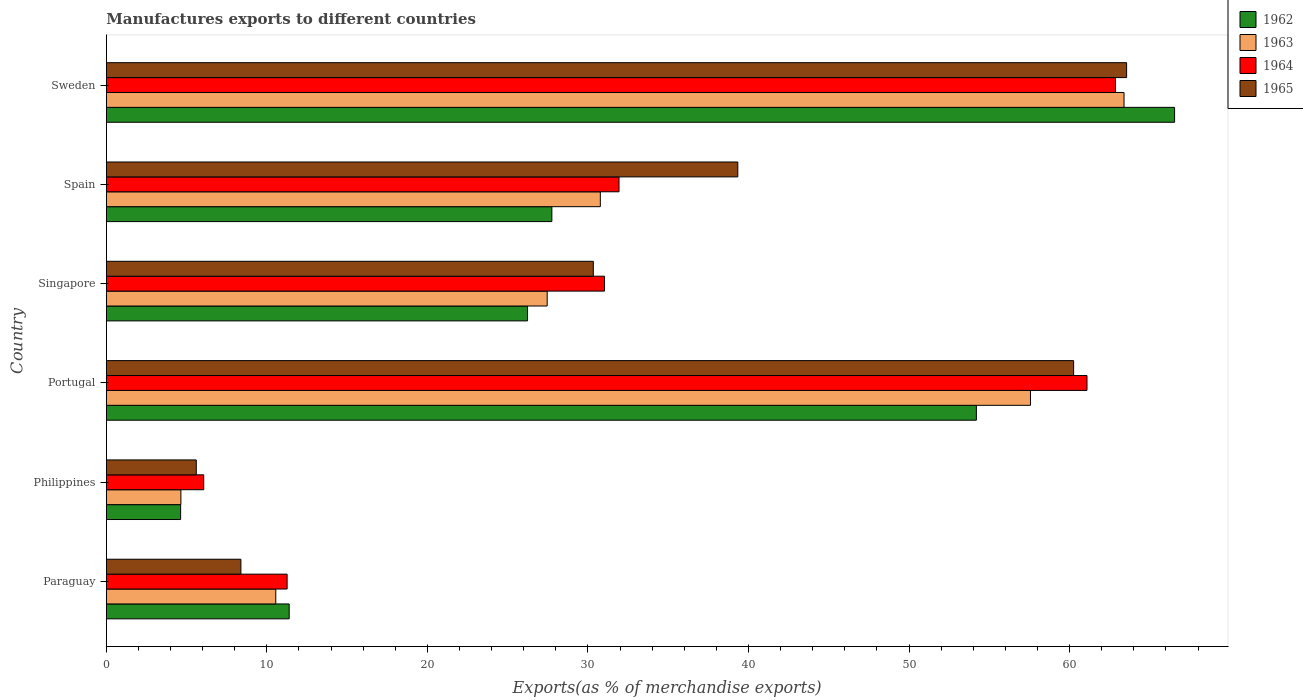Are the number of bars per tick equal to the number of legend labels?
Offer a terse response. Yes. In how many cases, is the number of bars for a given country not equal to the number of legend labels?
Offer a terse response. 0. What is the percentage of exports to different countries in 1965 in Sweden?
Ensure brevity in your answer.  63.55. Across all countries, what is the maximum percentage of exports to different countries in 1964?
Keep it short and to the point. 62.86. Across all countries, what is the minimum percentage of exports to different countries in 1962?
Offer a very short reply. 4.63. In which country was the percentage of exports to different countries in 1965 maximum?
Your answer should be very brief. Sweden. What is the total percentage of exports to different countries in 1965 in the graph?
Give a very brief answer. 207.45. What is the difference between the percentage of exports to different countries in 1964 in Portugal and that in Sweden?
Make the answer very short. -1.77. What is the difference between the percentage of exports to different countries in 1962 in Sweden and the percentage of exports to different countries in 1964 in Philippines?
Ensure brevity in your answer.  60.47. What is the average percentage of exports to different countries in 1964 per country?
Give a very brief answer. 34.04. What is the difference between the percentage of exports to different countries in 1962 and percentage of exports to different countries in 1963 in Paraguay?
Give a very brief answer. 0.83. In how many countries, is the percentage of exports to different countries in 1963 greater than 22 %?
Provide a succinct answer. 4. What is the ratio of the percentage of exports to different countries in 1964 in Portugal to that in Singapore?
Your answer should be compact. 1.97. Is the difference between the percentage of exports to different countries in 1962 in Paraguay and Portugal greater than the difference between the percentage of exports to different countries in 1963 in Paraguay and Portugal?
Your response must be concise. Yes. What is the difference between the highest and the second highest percentage of exports to different countries in 1962?
Your answer should be compact. 12.35. What is the difference between the highest and the lowest percentage of exports to different countries in 1965?
Provide a succinct answer. 57.95. In how many countries, is the percentage of exports to different countries in 1965 greater than the average percentage of exports to different countries in 1965 taken over all countries?
Provide a succinct answer. 3. What does the 1st bar from the top in Singapore represents?
Offer a terse response. 1965. What does the 4th bar from the bottom in Philippines represents?
Make the answer very short. 1965. Is it the case that in every country, the sum of the percentage of exports to different countries in 1964 and percentage of exports to different countries in 1965 is greater than the percentage of exports to different countries in 1963?
Provide a succinct answer. Yes. Are all the bars in the graph horizontal?
Provide a succinct answer. Yes. Does the graph contain grids?
Provide a succinct answer. No. How many legend labels are there?
Your response must be concise. 4. How are the legend labels stacked?
Make the answer very short. Vertical. What is the title of the graph?
Your answer should be very brief. Manufactures exports to different countries. Does "1995" appear as one of the legend labels in the graph?
Give a very brief answer. No. What is the label or title of the X-axis?
Your response must be concise. Exports(as % of merchandise exports). What is the Exports(as % of merchandise exports) of 1962 in Paraguay?
Your answer should be compact. 11.39. What is the Exports(as % of merchandise exports) in 1963 in Paraguay?
Provide a short and direct response. 10.55. What is the Exports(as % of merchandise exports) in 1964 in Paraguay?
Give a very brief answer. 11.26. What is the Exports(as % of merchandise exports) of 1965 in Paraguay?
Make the answer very short. 8.38. What is the Exports(as % of merchandise exports) of 1962 in Philippines?
Provide a succinct answer. 4.63. What is the Exports(as % of merchandise exports) of 1963 in Philippines?
Provide a short and direct response. 4.64. What is the Exports(as % of merchandise exports) in 1964 in Philippines?
Your answer should be very brief. 6.07. What is the Exports(as % of merchandise exports) of 1965 in Philippines?
Keep it short and to the point. 5.6. What is the Exports(as % of merchandise exports) in 1962 in Portugal?
Ensure brevity in your answer.  54.19. What is the Exports(as % of merchandise exports) in 1963 in Portugal?
Provide a short and direct response. 57.56. What is the Exports(as % of merchandise exports) of 1964 in Portugal?
Provide a succinct answer. 61.08. What is the Exports(as % of merchandise exports) in 1965 in Portugal?
Your response must be concise. 60.25. What is the Exports(as % of merchandise exports) in 1962 in Singapore?
Offer a terse response. 26.24. What is the Exports(as % of merchandise exports) of 1963 in Singapore?
Keep it short and to the point. 27.46. What is the Exports(as % of merchandise exports) of 1964 in Singapore?
Provide a short and direct response. 31.03. What is the Exports(as % of merchandise exports) of 1965 in Singapore?
Your response must be concise. 30.33. What is the Exports(as % of merchandise exports) of 1962 in Spain?
Offer a very short reply. 27.75. What is the Exports(as % of merchandise exports) in 1963 in Spain?
Provide a succinct answer. 30.77. What is the Exports(as % of merchandise exports) of 1964 in Spain?
Your answer should be compact. 31.93. What is the Exports(as % of merchandise exports) in 1965 in Spain?
Keep it short and to the point. 39.33. What is the Exports(as % of merchandise exports) in 1962 in Sweden?
Your answer should be very brief. 66.54. What is the Exports(as % of merchandise exports) of 1963 in Sweden?
Provide a short and direct response. 63.39. What is the Exports(as % of merchandise exports) in 1964 in Sweden?
Provide a short and direct response. 62.86. What is the Exports(as % of merchandise exports) in 1965 in Sweden?
Offer a very short reply. 63.55. Across all countries, what is the maximum Exports(as % of merchandise exports) of 1962?
Offer a very short reply. 66.54. Across all countries, what is the maximum Exports(as % of merchandise exports) of 1963?
Keep it short and to the point. 63.39. Across all countries, what is the maximum Exports(as % of merchandise exports) in 1964?
Provide a short and direct response. 62.86. Across all countries, what is the maximum Exports(as % of merchandise exports) of 1965?
Your answer should be very brief. 63.55. Across all countries, what is the minimum Exports(as % of merchandise exports) in 1962?
Offer a terse response. 4.63. Across all countries, what is the minimum Exports(as % of merchandise exports) in 1963?
Your answer should be compact. 4.64. Across all countries, what is the minimum Exports(as % of merchandise exports) in 1964?
Give a very brief answer. 6.07. Across all countries, what is the minimum Exports(as % of merchandise exports) of 1965?
Make the answer very short. 5.6. What is the total Exports(as % of merchandise exports) in 1962 in the graph?
Offer a terse response. 190.73. What is the total Exports(as % of merchandise exports) of 1963 in the graph?
Your answer should be compact. 194.38. What is the total Exports(as % of merchandise exports) in 1964 in the graph?
Ensure brevity in your answer.  204.23. What is the total Exports(as % of merchandise exports) of 1965 in the graph?
Your answer should be very brief. 207.45. What is the difference between the Exports(as % of merchandise exports) in 1962 in Paraguay and that in Philippines?
Keep it short and to the point. 6.76. What is the difference between the Exports(as % of merchandise exports) in 1963 in Paraguay and that in Philippines?
Keep it short and to the point. 5.91. What is the difference between the Exports(as % of merchandise exports) of 1964 in Paraguay and that in Philippines?
Your response must be concise. 5.19. What is the difference between the Exports(as % of merchandise exports) in 1965 in Paraguay and that in Philippines?
Give a very brief answer. 2.78. What is the difference between the Exports(as % of merchandise exports) of 1962 in Paraguay and that in Portugal?
Your answer should be compact. -42.8. What is the difference between the Exports(as % of merchandise exports) in 1963 in Paraguay and that in Portugal?
Give a very brief answer. -47.01. What is the difference between the Exports(as % of merchandise exports) in 1964 in Paraguay and that in Portugal?
Keep it short and to the point. -49.82. What is the difference between the Exports(as % of merchandise exports) of 1965 in Paraguay and that in Portugal?
Your answer should be very brief. -51.87. What is the difference between the Exports(as % of merchandise exports) in 1962 in Paraguay and that in Singapore?
Offer a terse response. -14.85. What is the difference between the Exports(as % of merchandise exports) of 1963 in Paraguay and that in Singapore?
Offer a terse response. -16.91. What is the difference between the Exports(as % of merchandise exports) of 1964 in Paraguay and that in Singapore?
Provide a succinct answer. -19.77. What is the difference between the Exports(as % of merchandise exports) in 1965 in Paraguay and that in Singapore?
Provide a succinct answer. -21.95. What is the difference between the Exports(as % of merchandise exports) of 1962 in Paraguay and that in Spain?
Ensure brevity in your answer.  -16.36. What is the difference between the Exports(as % of merchandise exports) of 1963 in Paraguay and that in Spain?
Offer a very short reply. -20.22. What is the difference between the Exports(as % of merchandise exports) of 1964 in Paraguay and that in Spain?
Offer a terse response. -20.67. What is the difference between the Exports(as % of merchandise exports) of 1965 in Paraguay and that in Spain?
Your answer should be very brief. -30.95. What is the difference between the Exports(as % of merchandise exports) of 1962 in Paraguay and that in Sweden?
Your answer should be compact. -55.15. What is the difference between the Exports(as % of merchandise exports) in 1963 in Paraguay and that in Sweden?
Ensure brevity in your answer.  -52.83. What is the difference between the Exports(as % of merchandise exports) in 1964 in Paraguay and that in Sweden?
Make the answer very short. -51.6. What is the difference between the Exports(as % of merchandise exports) of 1965 in Paraguay and that in Sweden?
Ensure brevity in your answer.  -55.17. What is the difference between the Exports(as % of merchandise exports) in 1962 in Philippines and that in Portugal?
Offer a terse response. -49.57. What is the difference between the Exports(as % of merchandise exports) in 1963 in Philippines and that in Portugal?
Ensure brevity in your answer.  -52.92. What is the difference between the Exports(as % of merchandise exports) of 1964 in Philippines and that in Portugal?
Your answer should be very brief. -55.02. What is the difference between the Exports(as % of merchandise exports) in 1965 in Philippines and that in Portugal?
Ensure brevity in your answer.  -54.65. What is the difference between the Exports(as % of merchandise exports) in 1962 in Philippines and that in Singapore?
Provide a short and direct response. -21.61. What is the difference between the Exports(as % of merchandise exports) in 1963 in Philippines and that in Singapore?
Your answer should be very brief. -22.82. What is the difference between the Exports(as % of merchandise exports) of 1964 in Philippines and that in Singapore?
Provide a succinct answer. -24.96. What is the difference between the Exports(as % of merchandise exports) in 1965 in Philippines and that in Singapore?
Your response must be concise. -24.73. What is the difference between the Exports(as % of merchandise exports) of 1962 in Philippines and that in Spain?
Offer a very short reply. -23.12. What is the difference between the Exports(as % of merchandise exports) of 1963 in Philippines and that in Spain?
Your response must be concise. -26.13. What is the difference between the Exports(as % of merchandise exports) in 1964 in Philippines and that in Spain?
Provide a short and direct response. -25.87. What is the difference between the Exports(as % of merchandise exports) of 1965 in Philippines and that in Spain?
Provide a short and direct response. -33.73. What is the difference between the Exports(as % of merchandise exports) of 1962 in Philippines and that in Sweden?
Ensure brevity in your answer.  -61.91. What is the difference between the Exports(as % of merchandise exports) in 1963 in Philippines and that in Sweden?
Give a very brief answer. -58.74. What is the difference between the Exports(as % of merchandise exports) in 1964 in Philippines and that in Sweden?
Offer a very short reply. -56.79. What is the difference between the Exports(as % of merchandise exports) of 1965 in Philippines and that in Sweden?
Give a very brief answer. -57.95. What is the difference between the Exports(as % of merchandise exports) of 1962 in Portugal and that in Singapore?
Offer a terse response. 27.96. What is the difference between the Exports(as % of merchandise exports) in 1963 in Portugal and that in Singapore?
Provide a short and direct response. 30.1. What is the difference between the Exports(as % of merchandise exports) of 1964 in Portugal and that in Singapore?
Give a very brief answer. 30.05. What is the difference between the Exports(as % of merchandise exports) in 1965 in Portugal and that in Singapore?
Make the answer very short. 29.92. What is the difference between the Exports(as % of merchandise exports) of 1962 in Portugal and that in Spain?
Keep it short and to the point. 26.44. What is the difference between the Exports(as % of merchandise exports) in 1963 in Portugal and that in Spain?
Offer a terse response. 26.79. What is the difference between the Exports(as % of merchandise exports) of 1964 in Portugal and that in Spain?
Your answer should be compact. 29.15. What is the difference between the Exports(as % of merchandise exports) of 1965 in Portugal and that in Spain?
Ensure brevity in your answer.  20.92. What is the difference between the Exports(as % of merchandise exports) in 1962 in Portugal and that in Sweden?
Your answer should be compact. -12.35. What is the difference between the Exports(as % of merchandise exports) of 1963 in Portugal and that in Sweden?
Your response must be concise. -5.83. What is the difference between the Exports(as % of merchandise exports) in 1964 in Portugal and that in Sweden?
Offer a very short reply. -1.77. What is the difference between the Exports(as % of merchandise exports) of 1965 in Portugal and that in Sweden?
Offer a terse response. -3.3. What is the difference between the Exports(as % of merchandise exports) of 1962 in Singapore and that in Spain?
Ensure brevity in your answer.  -1.51. What is the difference between the Exports(as % of merchandise exports) of 1963 in Singapore and that in Spain?
Provide a succinct answer. -3.31. What is the difference between the Exports(as % of merchandise exports) in 1964 in Singapore and that in Spain?
Your answer should be compact. -0.9. What is the difference between the Exports(as % of merchandise exports) of 1965 in Singapore and that in Spain?
Offer a very short reply. -9. What is the difference between the Exports(as % of merchandise exports) in 1962 in Singapore and that in Sweden?
Offer a very short reply. -40.3. What is the difference between the Exports(as % of merchandise exports) in 1963 in Singapore and that in Sweden?
Make the answer very short. -35.93. What is the difference between the Exports(as % of merchandise exports) of 1964 in Singapore and that in Sweden?
Keep it short and to the point. -31.83. What is the difference between the Exports(as % of merchandise exports) in 1965 in Singapore and that in Sweden?
Make the answer very short. -33.22. What is the difference between the Exports(as % of merchandise exports) in 1962 in Spain and that in Sweden?
Provide a short and direct response. -38.79. What is the difference between the Exports(as % of merchandise exports) of 1963 in Spain and that in Sweden?
Give a very brief answer. -32.62. What is the difference between the Exports(as % of merchandise exports) of 1964 in Spain and that in Sweden?
Make the answer very short. -30.92. What is the difference between the Exports(as % of merchandise exports) of 1965 in Spain and that in Sweden?
Ensure brevity in your answer.  -24.22. What is the difference between the Exports(as % of merchandise exports) in 1962 in Paraguay and the Exports(as % of merchandise exports) in 1963 in Philippines?
Your answer should be very brief. 6.75. What is the difference between the Exports(as % of merchandise exports) of 1962 in Paraguay and the Exports(as % of merchandise exports) of 1964 in Philippines?
Give a very brief answer. 5.32. What is the difference between the Exports(as % of merchandise exports) in 1962 in Paraguay and the Exports(as % of merchandise exports) in 1965 in Philippines?
Provide a short and direct response. 5.79. What is the difference between the Exports(as % of merchandise exports) in 1963 in Paraguay and the Exports(as % of merchandise exports) in 1964 in Philippines?
Your response must be concise. 4.49. What is the difference between the Exports(as % of merchandise exports) in 1963 in Paraguay and the Exports(as % of merchandise exports) in 1965 in Philippines?
Your response must be concise. 4.95. What is the difference between the Exports(as % of merchandise exports) in 1964 in Paraguay and the Exports(as % of merchandise exports) in 1965 in Philippines?
Provide a succinct answer. 5.66. What is the difference between the Exports(as % of merchandise exports) in 1962 in Paraguay and the Exports(as % of merchandise exports) in 1963 in Portugal?
Provide a succinct answer. -46.17. What is the difference between the Exports(as % of merchandise exports) in 1962 in Paraguay and the Exports(as % of merchandise exports) in 1964 in Portugal?
Provide a short and direct response. -49.69. What is the difference between the Exports(as % of merchandise exports) of 1962 in Paraguay and the Exports(as % of merchandise exports) of 1965 in Portugal?
Your answer should be very brief. -48.86. What is the difference between the Exports(as % of merchandise exports) of 1963 in Paraguay and the Exports(as % of merchandise exports) of 1964 in Portugal?
Ensure brevity in your answer.  -50.53. What is the difference between the Exports(as % of merchandise exports) of 1963 in Paraguay and the Exports(as % of merchandise exports) of 1965 in Portugal?
Your answer should be very brief. -49.7. What is the difference between the Exports(as % of merchandise exports) of 1964 in Paraguay and the Exports(as % of merchandise exports) of 1965 in Portugal?
Provide a succinct answer. -48.99. What is the difference between the Exports(as % of merchandise exports) in 1962 in Paraguay and the Exports(as % of merchandise exports) in 1963 in Singapore?
Your answer should be very brief. -16.07. What is the difference between the Exports(as % of merchandise exports) of 1962 in Paraguay and the Exports(as % of merchandise exports) of 1964 in Singapore?
Offer a terse response. -19.64. What is the difference between the Exports(as % of merchandise exports) of 1962 in Paraguay and the Exports(as % of merchandise exports) of 1965 in Singapore?
Provide a succinct answer. -18.94. What is the difference between the Exports(as % of merchandise exports) in 1963 in Paraguay and the Exports(as % of merchandise exports) in 1964 in Singapore?
Your answer should be compact. -20.48. What is the difference between the Exports(as % of merchandise exports) in 1963 in Paraguay and the Exports(as % of merchandise exports) in 1965 in Singapore?
Your answer should be compact. -19.78. What is the difference between the Exports(as % of merchandise exports) of 1964 in Paraguay and the Exports(as % of merchandise exports) of 1965 in Singapore?
Give a very brief answer. -19.07. What is the difference between the Exports(as % of merchandise exports) of 1962 in Paraguay and the Exports(as % of merchandise exports) of 1963 in Spain?
Your answer should be compact. -19.38. What is the difference between the Exports(as % of merchandise exports) in 1962 in Paraguay and the Exports(as % of merchandise exports) in 1964 in Spain?
Make the answer very short. -20.54. What is the difference between the Exports(as % of merchandise exports) of 1962 in Paraguay and the Exports(as % of merchandise exports) of 1965 in Spain?
Make the answer very short. -27.94. What is the difference between the Exports(as % of merchandise exports) of 1963 in Paraguay and the Exports(as % of merchandise exports) of 1964 in Spain?
Ensure brevity in your answer.  -21.38. What is the difference between the Exports(as % of merchandise exports) in 1963 in Paraguay and the Exports(as % of merchandise exports) in 1965 in Spain?
Offer a terse response. -28.78. What is the difference between the Exports(as % of merchandise exports) in 1964 in Paraguay and the Exports(as % of merchandise exports) in 1965 in Spain?
Make the answer very short. -28.07. What is the difference between the Exports(as % of merchandise exports) of 1962 in Paraguay and the Exports(as % of merchandise exports) of 1963 in Sweden?
Make the answer very short. -52. What is the difference between the Exports(as % of merchandise exports) in 1962 in Paraguay and the Exports(as % of merchandise exports) in 1964 in Sweden?
Offer a very short reply. -51.47. What is the difference between the Exports(as % of merchandise exports) of 1962 in Paraguay and the Exports(as % of merchandise exports) of 1965 in Sweden?
Give a very brief answer. -52.16. What is the difference between the Exports(as % of merchandise exports) of 1963 in Paraguay and the Exports(as % of merchandise exports) of 1964 in Sweden?
Offer a very short reply. -52.3. What is the difference between the Exports(as % of merchandise exports) of 1963 in Paraguay and the Exports(as % of merchandise exports) of 1965 in Sweden?
Provide a succinct answer. -52.99. What is the difference between the Exports(as % of merchandise exports) of 1964 in Paraguay and the Exports(as % of merchandise exports) of 1965 in Sweden?
Provide a short and direct response. -52.29. What is the difference between the Exports(as % of merchandise exports) of 1962 in Philippines and the Exports(as % of merchandise exports) of 1963 in Portugal?
Provide a short and direct response. -52.93. What is the difference between the Exports(as % of merchandise exports) of 1962 in Philippines and the Exports(as % of merchandise exports) of 1964 in Portugal?
Your response must be concise. -56.46. What is the difference between the Exports(as % of merchandise exports) in 1962 in Philippines and the Exports(as % of merchandise exports) in 1965 in Portugal?
Your response must be concise. -55.62. What is the difference between the Exports(as % of merchandise exports) in 1963 in Philippines and the Exports(as % of merchandise exports) in 1964 in Portugal?
Give a very brief answer. -56.44. What is the difference between the Exports(as % of merchandise exports) of 1963 in Philippines and the Exports(as % of merchandise exports) of 1965 in Portugal?
Provide a succinct answer. -55.61. What is the difference between the Exports(as % of merchandise exports) of 1964 in Philippines and the Exports(as % of merchandise exports) of 1965 in Portugal?
Your answer should be compact. -54.18. What is the difference between the Exports(as % of merchandise exports) of 1962 in Philippines and the Exports(as % of merchandise exports) of 1963 in Singapore?
Keep it short and to the point. -22.83. What is the difference between the Exports(as % of merchandise exports) of 1962 in Philippines and the Exports(as % of merchandise exports) of 1964 in Singapore?
Ensure brevity in your answer.  -26.4. What is the difference between the Exports(as % of merchandise exports) of 1962 in Philippines and the Exports(as % of merchandise exports) of 1965 in Singapore?
Your answer should be very brief. -25.7. What is the difference between the Exports(as % of merchandise exports) in 1963 in Philippines and the Exports(as % of merchandise exports) in 1964 in Singapore?
Offer a very short reply. -26.39. What is the difference between the Exports(as % of merchandise exports) of 1963 in Philippines and the Exports(as % of merchandise exports) of 1965 in Singapore?
Give a very brief answer. -25.69. What is the difference between the Exports(as % of merchandise exports) in 1964 in Philippines and the Exports(as % of merchandise exports) in 1965 in Singapore?
Keep it short and to the point. -24.27. What is the difference between the Exports(as % of merchandise exports) of 1962 in Philippines and the Exports(as % of merchandise exports) of 1963 in Spain?
Your answer should be very brief. -26.14. What is the difference between the Exports(as % of merchandise exports) in 1962 in Philippines and the Exports(as % of merchandise exports) in 1964 in Spain?
Keep it short and to the point. -27.31. What is the difference between the Exports(as % of merchandise exports) of 1962 in Philippines and the Exports(as % of merchandise exports) of 1965 in Spain?
Provide a succinct answer. -34.71. What is the difference between the Exports(as % of merchandise exports) of 1963 in Philippines and the Exports(as % of merchandise exports) of 1964 in Spain?
Offer a very short reply. -27.29. What is the difference between the Exports(as % of merchandise exports) of 1963 in Philippines and the Exports(as % of merchandise exports) of 1965 in Spain?
Offer a terse response. -34.69. What is the difference between the Exports(as % of merchandise exports) of 1964 in Philippines and the Exports(as % of merchandise exports) of 1965 in Spain?
Your response must be concise. -33.27. What is the difference between the Exports(as % of merchandise exports) in 1962 in Philippines and the Exports(as % of merchandise exports) in 1963 in Sweden?
Give a very brief answer. -58.76. What is the difference between the Exports(as % of merchandise exports) of 1962 in Philippines and the Exports(as % of merchandise exports) of 1964 in Sweden?
Your answer should be compact. -58.23. What is the difference between the Exports(as % of merchandise exports) of 1962 in Philippines and the Exports(as % of merchandise exports) of 1965 in Sweden?
Offer a terse response. -58.92. What is the difference between the Exports(as % of merchandise exports) in 1963 in Philippines and the Exports(as % of merchandise exports) in 1964 in Sweden?
Your answer should be compact. -58.21. What is the difference between the Exports(as % of merchandise exports) of 1963 in Philippines and the Exports(as % of merchandise exports) of 1965 in Sweden?
Provide a succinct answer. -58.91. What is the difference between the Exports(as % of merchandise exports) of 1964 in Philippines and the Exports(as % of merchandise exports) of 1965 in Sweden?
Offer a terse response. -57.48. What is the difference between the Exports(as % of merchandise exports) of 1962 in Portugal and the Exports(as % of merchandise exports) of 1963 in Singapore?
Keep it short and to the point. 26.73. What is the difference between the Exports(as % of merchandise exports) of 1962 in Portugal and the Exports(as % of merchandise exports) of 1964 in Singapore?
Keep it short and to the point. 23.16. What is the difference between the Exports(as % of merchandise exports) in 1962 in Portugal and the Exports(as % of merchandise exports) in 1965 in Singapore?
Your answer should be very brief. 23.86. What is the difference between the Exports(as % of merchandise exports) of 1963 in Portugal and the Exports(as % of merchandise exports) of 1964 in Singapore?
Offer a very short reply. 26.53. What is the difference between the Exports(as % of merchandise exports) of 1963 in Portugal and the Exports(as % of merchandise exports) of 1965 in Singapore?
Give a very brief answer. 27.23. What is the difference between the Exports(as % of merchandise exports) of 1964 in Portugal and the Exports(as % of merchandise exports) of 1965 in Singapore?
Offer a terse response. 30.75. What is the difference between the Exports(as % of merchandise exports) in 1962 in Portugal and the Exports(as % of merchandise exports) in 1963 in Spain?
Ensure brevity in your answer.  23.42. What is the difference between the Exports(as % of merchandise exports) in 1962 in Portugal and the Exports(as % of merchandise exports) in 1964 in Spain?
Your answer should be very brief. 22.26. What is the difference between the Exports(as % of merchandise exports) in 1962 in Portugal and the Exports(as % of merchandise exports) in 1965 in Spain?
Keep it short and to the point. 14.86. What is the difference between the Exports(as % of merchandise exports) of 1963 in Portugal and the Exports(as % of merchandise exports) of 1964 in Spain?
Your answer should be compact. 25.63. What is the difference between the Exports(as % of merchandise exports) in 1963 in Portugal and the Exports(as % of merchandise exports) in 1965 in Spain?
Make the answer very short. 18.23. What is the difference between the Exports(as % of merchandise exports) in 1964 in Portugal and the Exports(as % of merchandise exports) in 1965 in Spain?
Offer a terse response. 21.75. What is the difference between the Exports(as % of merchandise exports) in 1962 in Portugal and the Exports(as % of merchandise exports) in 1963 in Sweden?
Make the answer very short. -9.2. What is the difference between the Exports(as % of merchandise exports) in 1962 in Portugal and the Exports(as % of merchandise exports) in 1964 in Sweden?
Your answer should be very brief. -8.66. What is the difference between the Exports(as % of merchandise exports) in 1962 in Portugal and the Exports(as % of merchandise exports) in 1965 in Sweden?
Offer a very short reply. -9.36. What is the difference between the Exports(as % of merchandise exports) in 1963 in Portugal and the Exports(as % of merchandise exports) in 1964 in Sweden?
Give a very brief answer. -5.3. What is the difference between the Exports(as % of merchandise exports) of 1963 in Portugal and the Exports(as % of merchandise exports) of 1965 in Sweden?
Your answer should be compact. -5.99. What is the difference between the Exports(as % of merchandise exports) of 1964 in Portugal and the Exports(as % of merchandise exports) of 1965 in Sweden?
Provide a succinct answer. -2.47. What is the difference between the Exports(as % of merchandise exports) in 1962 in Singapore and the Exports(as % of merchandise exports) in 1963 in Spain?
Your answer should be compact. -4.53. What is the difference between the Exports(as % of merchandise exports) in 1962 in Singapore and the Exports(as % of merchandise exports) in 1964 in Spain?
Ensure brevity in your answer.  -5.7. What is the difference between the Exports(as % of merchandise exports) of 1962 in Singapore and the Exports(as % of merchandise exports) of 1965 in Spain?
Your response must be concise. -13.1. What is the difference between the Exports(as % of merchandise exports) in 1963 in Singapore and the Exports(as % of merchandise exports) in 1964 in Spain?
Ensure brevity in your answer.  -4.47. What is the difference between the Exports(as % of merchandise exports) in 1963 in Singapore and the Exports(as % of merchandise exports) in 1965 in Spain?
Give a very brief answer. -11.87. What is the difference between the Exports(as % of merchandise exports) in 1964 in Singapore and the Exports(as % of merchandise exports) in 1965 in Spain?
Offer a very short reply. -8.3. What is the difference between the Exports(as % of merchandise exports) in 1962 in Singapore and the Exports(as % of merchandise exports) in 1963 in Sweden?
Provide a short and direct response. -37.15. What is the difference between the Exports(as % of merchandise exports) of 1962 in Singapore and the Exports(as % of merchandise exports) of 1964 in Sweden?
Your answer should be very brief. -36.62. What is the difference between the Exports(as % of merchandise exports) of 1962 in Singapore and the Exports(as % of merchandise exports) of 1965 in Sweden?
Your answer should be compact. -37.31. What is the difference between the Exports(as % of merchandise exports) of 1963 in Singapore and the Exports(as % of merchandise exports) of 1964 in Sweden?
Offer a very short reply. -35.4. What is the difference between the Exports(as % of merchandise exports) of 1963 in Singapore and the Exports(as % of merchandise exports) of 1965 in Sweden?
Ensure brevity in your answer.  -36.09. What is the difference between the Exports(as % of merchandise exports) in 1964 in Singapore and the Exports(as % of merchandise exports) in 1965 in Sweden?
Offer a terse response. -32.52. What is the difference between the Exports(as % of merchandise exports) of 1962 in Spain and the Exports(as % of merchandise exports) of 1963 in Sweden?
Offer a very short reply. -35.64. What is the difference between the Exports(as % of merchandise exports) of 1962 in Spain and the Exports(as % of merchandise exports) of 1964 in Sweden?
Ensure brevity in your answer.  -35.11. What is the difference between the Exports(as % of merchandise exports) in 1962 in Spain and the Exports(as % of merchandise exports) in 1965 in Sweden?
Offer a very short reply. -35.8. What is the difference between the Exports(as % of merchandise exports) of 1963 in Spain and the Exports(as % of merchandise exports) of 1964 in Sweden?
Your response must be concise. -32.09. What is the difference between the Exports(as % of merchandise exports) of 1963 in Spain and the Exports(as % of merchandise exports) of 1965 in Sweden?
Provide a succinct answer. -32.78. What is the difference between the Exports(as % of merchandise exports) of 1964 in Spain and the Exports(as % of merchandise exports) of 1965 in Sweden?
Make the answer very short. -31.62. What is the average Exports(as % of merchandise exports) of 1962 per country?
Ensure brevity in your answer.  31.79. What is the average Exports(as % of merchandise exports) of 1963 per country?
Make the answer very short. 32.4. What is the average Exports(as % of merchandise exports) in 1964 per country?
Keep it short and to the point. 34.04. What is the average Exports(as % of merchandise exports) of 1965 per country?
Ensure brevity in your answer.  34.57. What is the difference between the Exports(as % of merchandise exports) of 1962 and Exports(as % of merchandise exports) of 1963 in Paraguay?
Offer a terse response. 0.83. What is the difference between the Exports(as % of merchandise exports) in 1962 and Exports(as % of merchandise exports) in 1964 in Paraguay?
Offer a very short reply. 0.13. What is the difference between the Exports(as % of merchandise exports) of 1962 and Exports(as % of merchandise exports) of 1965 in Paraguay?
Your answer should be compact. 3.01. What is the difference between the Exports(as % of merchandise exports) of 1963 and Exports(as % of merchandise exports) of 1964 in Paraguay?
Give a very brief answer. -0.71. What is the difference between the Exports(as % of merchandise exports) of 1963 and Exports(as % of merchandise exports) of 1965 in Paraguay?
Your answer should be very brief. 2.17. What is the difference between the Exports(as % of merchandise exports) in 1964 and Exports(as % of merchandise exports) in 1965 in Paraguay?
Offer a terse response. 2.88. What is the difference between the Exports(as % of merchandise exports) in 1962 and Exports(as % of merchandise exports) in 1963 in Philippines?
Provide a succinct answer. -0.02. What is the difference between the Exports(as % of merchandise exports) of 1962 and Exports(as % of merchandise exports) of 1964 in Philippines?
Offer a terse response. -1.44. What is the difference between the Exports(as % of merchandise exports) of 1962 and Exports(as % of merchandise exports) of 1965 in Philippines?
Provide a short and direct response. -0.98. What is the difference between the Exports(as % of merchandise exports) in 1963 and Exports(as % of merchandise exports) in 1964 in Philippines?
Your answer should be very brief. -1.42. What is the difference between the Exports(as % of merchandise exports) of 1963 and Exports(as % of merchandise exports) of 1965 in Philippines?
Give a very brief answer. -0.96. What is the difference between the Exports(as % of merchandise exports) of 1964 and Exports(as % of merchandise exports) of 1965 in Philippines?
Provide a short and direct response. 0.46. What is the difference between the Exports(as % of merchandise exports) of 1962 and Exports(as % of merchandise exports) of 1963 in Portugal?
Offer a terse response. -3.37. What is the difference between the Exports(as % of merchandise exports) in 1962 and Exports(as % of merchandise exports) in 1964 in Portugal?
Provide a short and direct response. -6.89. What is the difference between the Exports(as % of merchandise exports) in 1962 and Exports(as % of merchandise exports) in 1965 in Portugal?
Make the answer very short. -6.06. What is the difference between the Exports(as % of merchandise exports) of 1963 and Exports(as % of merchandise exports) of 1964 in Portugal?
Keep it short and to the point. -3.52. What is the difference between the Exports(as % of merchandise exports) in 1963 and Exports(as % of merchandise exports) in 1965 in Portugal?
Your answer should be very brief. -2.69. What is the difference between the Exports(as % of merchandise exports) in 1964 and Exports(as % of merchandise exports) in 1965 in Portugal?
Offer a terse response. 0.83. What is the difference between the Exports(as % of merchandise exports) of 1962 and Exports(as % of merchandise exports) of 1963 in Singapore?
Provide a succinct answer. -1.22. What is the difference between the Exports(as % of merchandise exports) of 1962 and Exports(as % of merchandise exports) of 1964 in Singapore?
Provide a succinct answer. -4.79. What is the difference between the Exports(as % of merchandise exports) in 1962 and Exports(as % of merchandise exports) in 1965 in Singapore?
Offer a very short reply. -4.1. What is the difference between the Exports(as % of merchandise exports) of 1963 and Exports(as % of merchandise exports) of 1964 in Singapore?
Make the answer very short. -3.57. What is the difference between the Exports(as % of merchandise exports) in 1963 and Exports(as % of merchandise exports) in 1965 in Singapore?
Offer a very short reply. -2.87. What is the difference between the Exports(as % of merchandise exports) in 1964 and Exports(as % of merchandise exports) in 1965 in Singapore?
Ensure brevity in your answer.  0.7. What is the difference between the Exports(as % of merchandise exports) in 1962 and Exports(as % of merchandise exports) in 1963 in Spain?
Give a very brief answer. -3.02. What is the difference between the Exports(as % of merchandise exports) of 1962 and Exports(as % of merchandise exports) of 1964 in Spain?
Your answer should be compact. -4.18. What is the difference between the Exports(as % of merchandise exports) of 1962 and Exports(as % of merchandise exports) of 1965 in Spain?
Your answer should be very brief. -11.58. What is the difference between the Exports(as % of merchandise exports) in 1963 and Exports(as % of merchandise exports) in 1964 in Spain?
Your answer should be very brief. -1.16. What is the difference between the Exports(as % of merchandise exports) of 1963 and Exports(as % of merchandise exports) of 1965 in Spain?
Your response must be concise. -8.56. What is the difference between the Exports(as % of merchandise exports) in 1964 and Exports(as % of merchandise exports) in 1965 in Spain?
Keep it short and to the point. -7.4. What is the difference between the Exports(as % of merchandise exports) of 1962 and Exports(as % of merchandise exports) of 1963 in Sweden?
Offer a terse response. 3.15. What is the difference between the Exports(as % of merchandise exports) of 1962 and Exports(as % of merchandise exports) of 1964 in Sweden?
Make the answer very short. 3.68. What is the difference between the Exports(as % of merchandise exports) of 1962 and Exports(as % of merchandise exports) of 1965 in Sweden?
Provide a short and direct response. 2.99. What is the difference between the Exports(as % of merchandise exports) in 1963 and Exports(as % of merchandise exports) in 1964 in Sweden?
Your answer should be compact. 0.53. What is the difference between the Exports(as % of merchandise exports) of 1963 and Exports(as % of merchandise exports) of 1965 in Sweden?
Offer a very short reply. -0.16. What is the difference between the Exports(as % of merchandise exports) in 1964 and Exports(as % of merchandise exports) in 1965 in Sweden?
Give a very brief answer. -0.69. What is the ratio of the Exports(as % of merchandise exports) of 1962 in Paraguay to that in Philippines?
Make the answer very short. 2.46. What is the ratio of the Exports(as % of merchandise exports) of 1963 in Paraguay to that in Philippines?
Your answer should be very brief. 2.27. What is the ratio of the Exports(as % of merchandise exports) of 1964 in Paraguay to that in Philippines?
Provide a succinct answer. 1.86. What is the ratio of the Exports(as % of merchandise exports) in 1965 in Paraguay to that in Philippines?
Give a very brief answer. 1.5. What is the ratio of the Exports(as % of merchandise exports) of 1962 in Paraguay to that in Portugal?
Give a very brief answer. 0.21. What is the ratio of the Exports(as % of merchandise exports) of 1963 in Paraguay to that in Portugal?
Keep it short and to the point. 0.18. What is the ratio of the Exports(as % of merchandise exports) in 1964 in Paraguay to that in Portugal?
Your response must be concise. 0.18. What is the ratio of the Exports(as % of merchandise exports) in 1965 in Paraguay to that in Portugal?
Your response must be concise. 0.14. What is the ratio of the Exports(as % of merchandise exports) in 1962 in Paraguay to that in Singapore?
Provide a succinct answer. 0.43. What is the ratio of the Exports(as % of merchandise exports) in 1963 in Paraguay to that in Singapore?
Provide a succinct answer. 0.38. What is the ratio of the Exports(as % of merchandise exports) of 1964 in Paraguay to that in Singapore?
Keep it short and to the point. 0.36. What is the ratio of the Exports(as % of merchandise exports) in 1965 in Paraguay to that in Singapore?
Your answer should be very brief. 0.28. What is the ratio of the Exports(as % of merchandise exports) of 1962 in Paraguay to that in Spain?
Your response must be concise. 0.41. What is the ratio of the Exports(as % of merchandise exports) in 1963 in Paraguay to that in Spain?
Your answer should be compact. 0.34. What is the ratio of the Exports(as % of merchandise exports) of 1964 in Paraguay to that in Spain?
Provide a succinct answer. 0.35. What is the ratio of the Exports(as % of merchandise exports) in 1965 in Paraguay to that in Spain?
Provide a succinct answer. 0.21. What is the ratio of the Exports(as % of merchandise exports) of 1962 in Paraguay to that in Sweden?
Your response must be concise. 0.17. What is the ratio of the Exports(as % of merchandise exports) of 1963 in Paraguay to that in Sweden?
Give a very brief answer. 0.17. What is the ratio of the Exports(as % of merchandise exports) of 1964 in Paraguay to that in Sweden?
Your answer should be compact. 0.18. What is the ratio of the Exports(as % of merchandise exports) of 1965 in Paraguay to that in Sweden?
Ensure brevity in your answer.  0.13. What is the ratio of the Exports(as % of merchandise exports) in 1962 in Philippines to that in Portugal?
Ensure brevity in your answer.  0.09. What is the ratio of the Exports(as % of merchandise exports) in 1963 in Philippines to that in Portugal?
Your response must be concise. 0.08. What is the ratio of the Exports(as % of merchandise exports) of 1964 in Philippines to that in Portugal?
Provide a short and direct response. 0.1. What is the ratio of the Exports(as % of merchandise exports) of 1965 in Philippines to that in Portugal?
Your answer should be compact. 0.09. What is the ratio of the Exports(as % of merchandise exports) in 1962 in Philippines to that in Singapore?
Ensure brevity in your answer.  0.18. What is the ratio of the Exports(as % of merchandise exports) in 1963 in Philippines to that in Singapore?
Ensure brevity in your answer.  0.17. What is the ratio of the Exports(as % of merchandise exports) of 1964 in Philippines to that in Singapore?
Provide a short and direct response. 0.2. What is the ratio of the Exports(as % of merchandise exports) in 1965 in Philippines to that in Singapore?
Provide a short and direct response. 0.18. What is the ratio of the Exports(as % of merchandise exports) of 1963 in Philippines to that in Spain?
Offer a terse response. 0.15. What is the ratio of the Exports(as % of merchandise exports) in 1964 in Philippines to that in Spain?
Your response must be concise. 0.19. What is the ratio of the Exports(as % of merchandise exports) in 1965 in Philippines to that in Spain?
Ensure brevity in your answer.  0.14. What is the ratio of the Exports(as % of merchandise exports) of 1962 in Philippines to that in Sweden?
Your response must be concise. 0.07. What is the ratio of the Exports(as % of merchandise exports) in 1963 in Philippines to that in Sweden?
Provide a succinct answer. 0.07. What is the ratio of the Exports(as % of merchandise exports) in 1964 in Philippines to that in Sweden?
Ensure brevity in your answer.  0.1. What is the ratio of the Exports(as % of merchandise exports) of 1965 in Philippines to that in Sweden?
Your answer should be compact. 0.09. What is the ratio of the Exports(as % of merchandise exports) in 1962 in Portugal to that in Singapore?
Your answer should be compact. 2.07. What is the ratio of the Exports(as % of merchandise exports) of 1963 in Portugal to that in Singapore?
Give a very brief answer. 2.1. What is the ratio of the Exports(as % of merchandise exports) of 1964 in Portugal to that in Singapore?
Ensure brevity in your answer.  1.97. What is the ratio of the Exports(as % of merchandise exports) in 1965 in Portugal to that in Singapore?
Offer a terse response. 1.99. What is the ratio of the Exports(as % of merchandise exports) in 1962 in Portugal to that in Spain?
Offer a terse response. 1.95. What is the ratio of the Exports(as % of merchandise exports) in 1963 in Portugal to that in Spain?
Offer a terse response. 1.87. What is the ratio of the Exports(as % of merchandise exports) of 1964 in Portugal to that in Spain?
Make the answer very short. 1.91. What is the ratio of the Exports(as % of merchandise exports) of 1965 in Portugal to that in Spain?
Your response must be concise. 1.53. What is the ratio of the Exports(as % of merchandise exports) of 1962 in Portugal to that in Sweden?
Make the answer very short. 0.81. What is the ratio of the Exports(as % of merchandise exports) of 1963 in Portugal to that in Sweden?
Offer a terse response. 0.91. What is the ratio of the Exports(as % of merchandise exports) in 1964 in Portugal to that in Sweden?
Provide a succinct answer. 0.97. What is the ratio of the Exports(as % of merchandise exports) in 1965 in Portugal to that in Sweden?
Your response must be concise. 0.95. What is the ratio of the Exports(as % of merchandise exports) in 1962 in Singapore to that in Spain?
Your answer should be very brief. 0.95. What is the ratio of the Exports(as % of merchandise exports) in 1963 in Singapore to that in Spain?
Offer a terse response. 0.89. What is the ratio of the Exports(as % of merchandise exports) in 1964 in Singapore to that in Spain?
Provide a succinct answer. 0.97. What is the ratio of the Exports(as % of merchandise exports) in 1965 in Singapore to that in Spain?
Keep it short and to the point. 0.77. What is the ratio of the Exports(as % of merchandise exports) of 1962 in Singapore to that in Sweden?
Your response must be concise. 0.39. What is the ratio of the Exports(as % of merchandise exports) in 1963 in Singapore to that in Sweden?
Ensure brevity in your answer.  0.43. What is the ratio of the Exports(as % of merchandise exports) in 1964 in Singapore to that in Sweden?
Ensure brevity in your answer.  0.49. What is the ratio of the Exports(as % of merchandise exports) in 1965 in Singapore to that in Sweden?
Make the answer very short. 0.48. What is the ratio of the Exports(as % of merchandise exports) of 1962 in Spain to that in Sweden?
Make the answer very short. 0.42. What is the ratio of the Exports(as % of merchandise exports) of 1963 in Spain to that in Sweden?
Your answer should be very brief. 0.49. What is the ratio of the Exports(as % of merchandise exports) of 1964 in Spain to that in Sweden?
Make the answer very short. 0.51. What is the ratio of the Exports(as % of merchandise exports) of 1965 in Spain to that in Sweden?
Offer a terse response. 0.62. What is the difference between the highest and the second highest Exports(as % of merchandise exports) of 1962?
Keep it short and to the point. 12.35. What is the difference between the highest and the second highest Exports(as % of merchandise exports) in 1963?
Keep it short and to the point. 5.83. What is the difference between the highest and the second highest Exports(as % of merchandise exports) in 1964?
Give a very brief answer. 1.77. What is the difference between the highest and the second highest Exports(as % of merchandise exports) in 1965?
Provide a succinct answer. 3.3. What is the difference between the highest and the lowest Exports(as % of merchandise exports) of 1962?
Your response must be concise. 61.91. What is the difference between the highest and the lowest Exports(as % of merchandise exports) in 1963?
Offer a terse response. 58.74. What is the difference between the highest and the lowest Exports(as % of merchandise exports) in 1964?
Provide a succinct answer. 56.79. What is the difference between the highest and the lowest Exports(as % of merchandise exports) of 1965?
Make the answer very short. 57.95. 